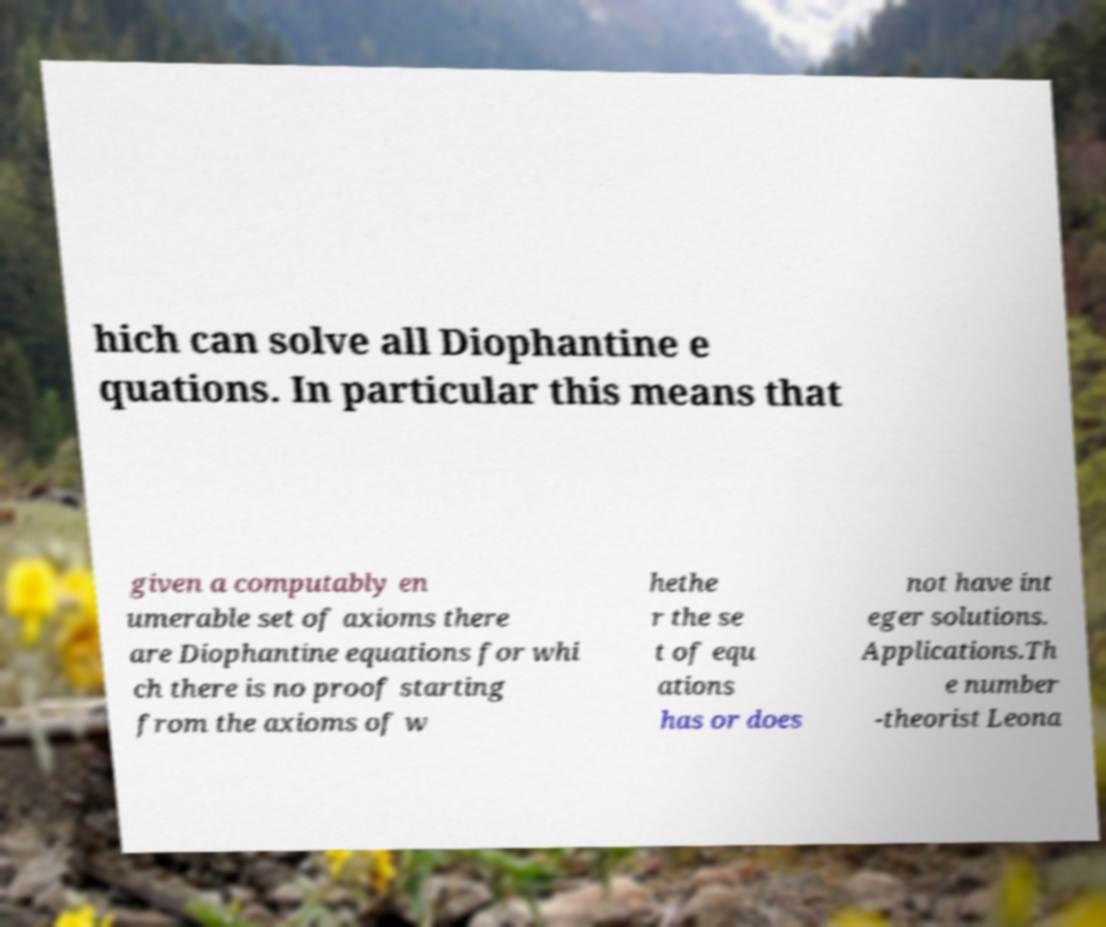I need the written content from this picture converted into text. Can you do that? hich can solve all Diophantine e quations. In particular this means that given a computably en umerable set of axioms there are Diophantine equations for whi ch there is no proof starting from the axioms of w hethe r the se t of equ ations has or does not have int eger solutions. Applications.Th e number -theorist Leona 